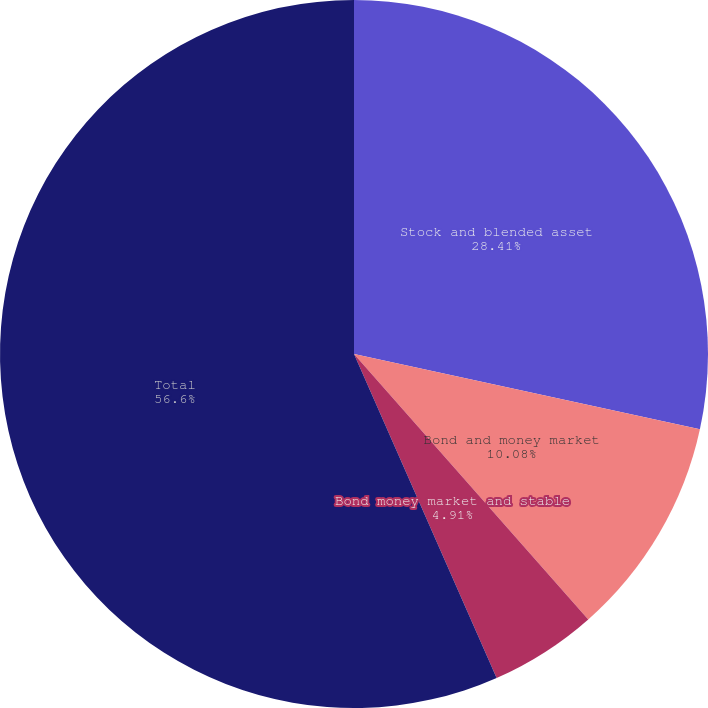<chart> <loc_0><loc_0><loc_500><loc_500><pie_chart><fcel>Stock and blended asset<fcel>Bond and money market<fcel>Bond money market and stable<fcel>Total<nl><fcel>28.41%<fcel>10.08%<fcel>4.91%<fcel>56.6%<nl></chart> 